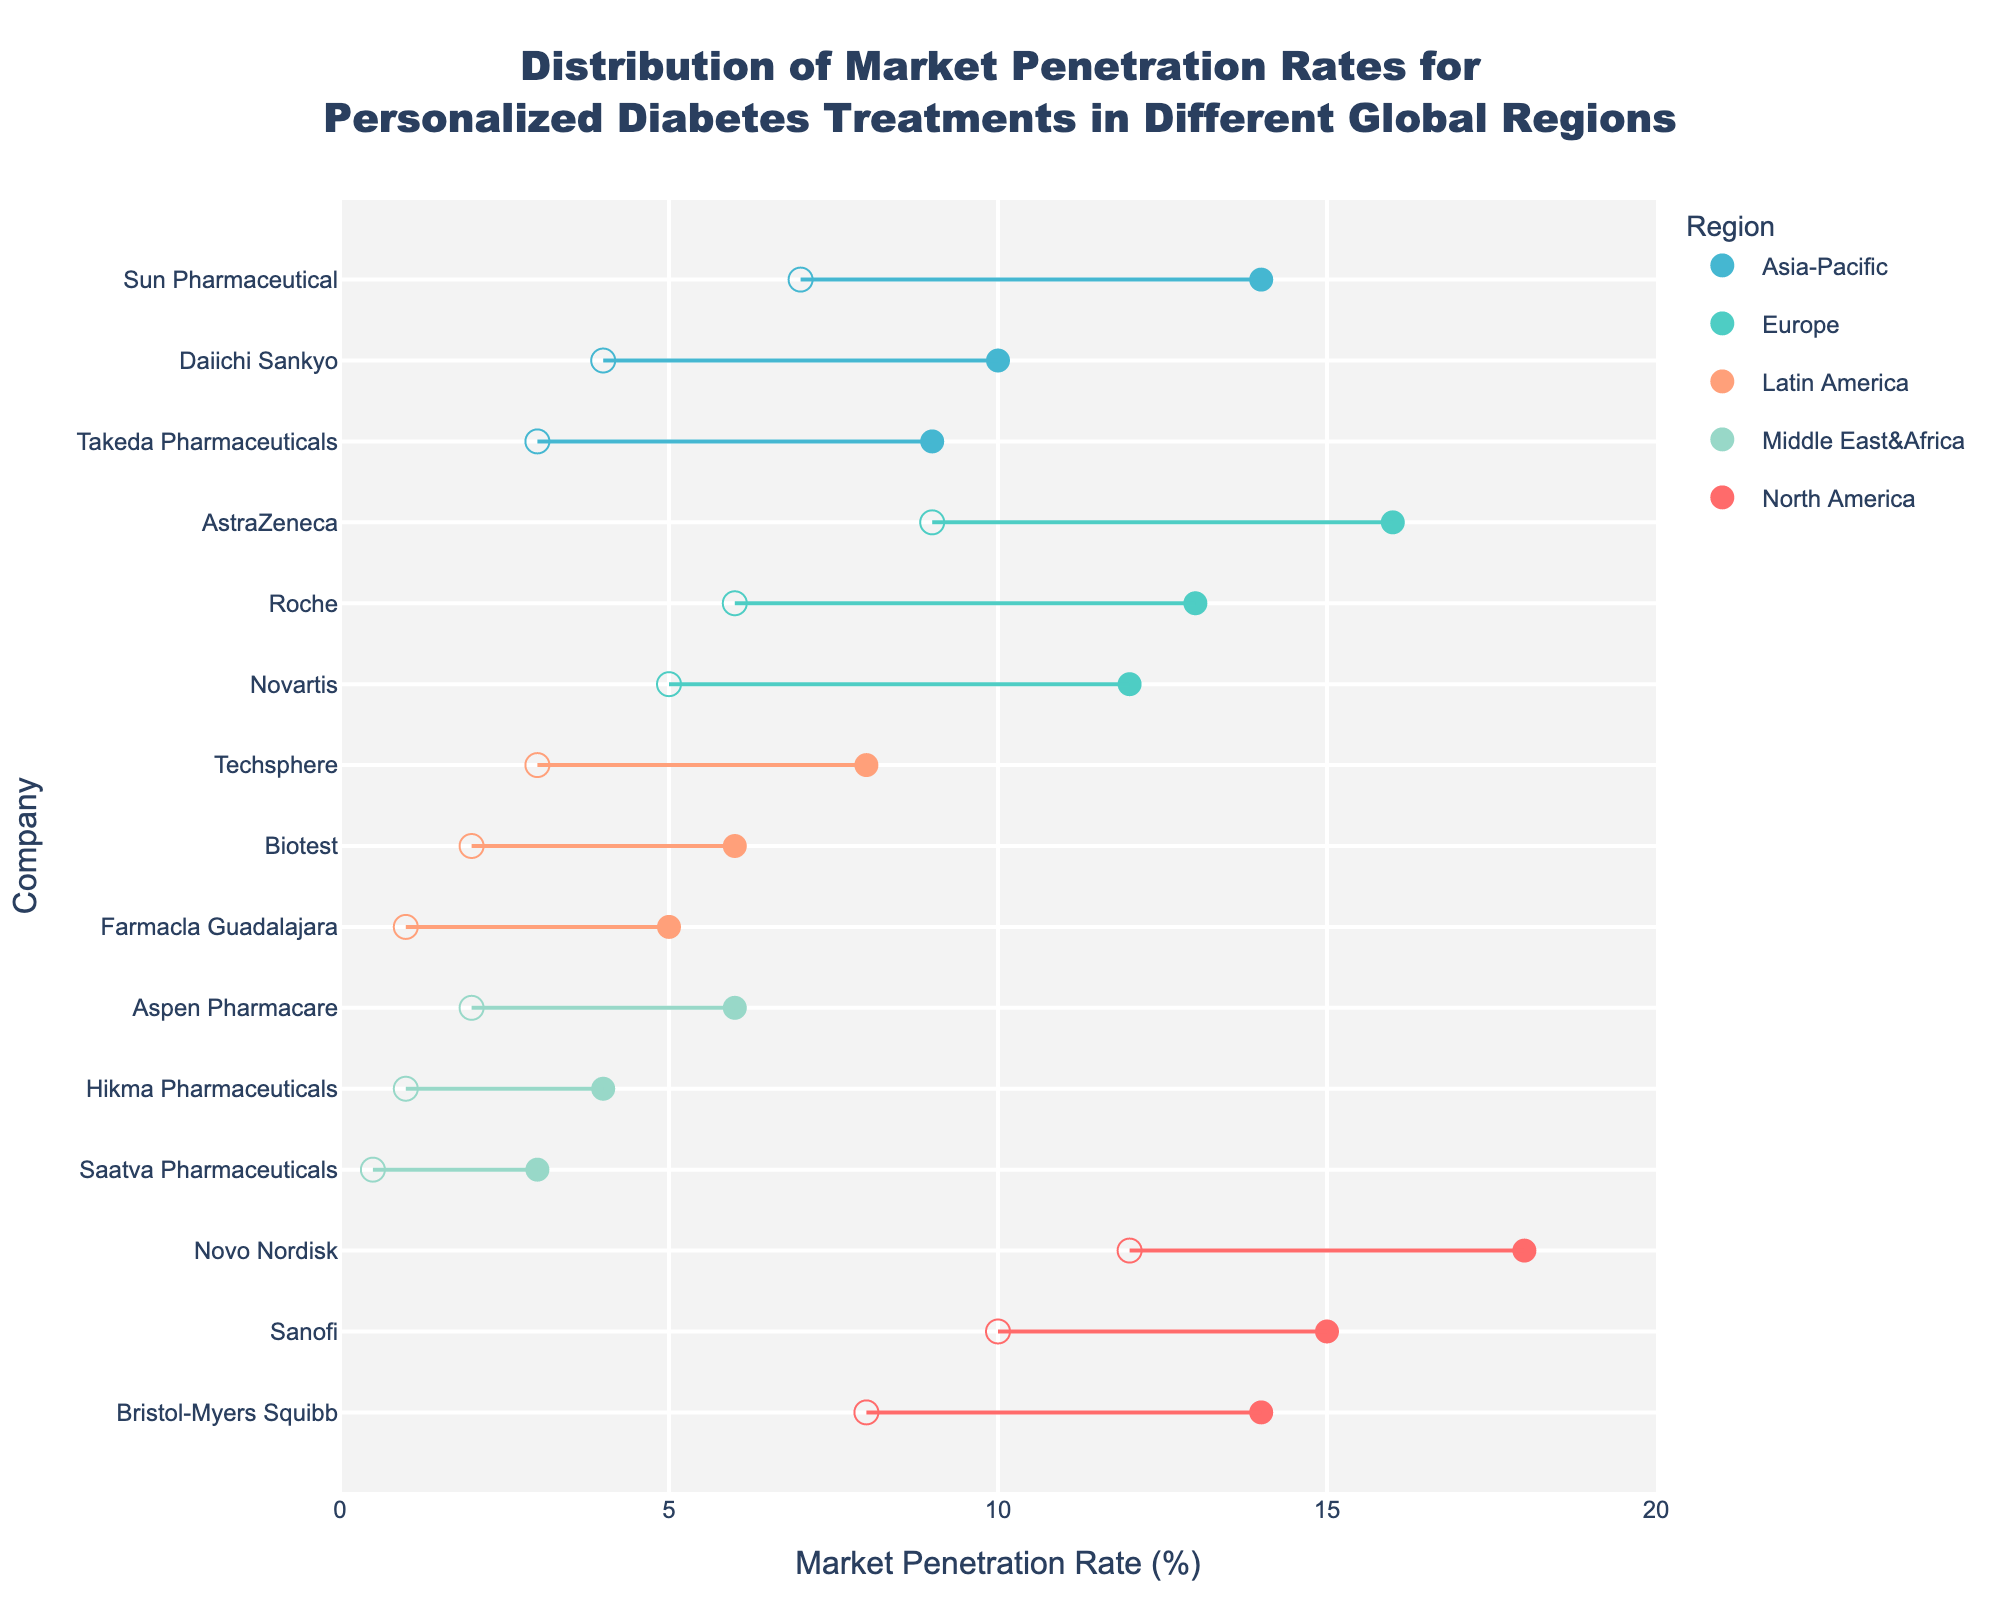What is the maximum market penetration rate for Novo Nordisk in North America? According to the figure, the maximum market penetration rate can be determined by finding where Novo Nordisk is represented in the North America region. The dot for Novo Nordisk in the North America section of the plot reaches up to a value of 18%.
Answer: 18% Which region has the company with the widest range of market penetration rates? The range can be calculated by subtracting the minimum penetration rate from the maximum for each company and then comparing these ranges. For example, Novo Nordisk in North America has a range of 18% - 12% = 6%. By checking each region, the Middle East&Africa with Saatva Pharmaceuticals (3% - 0.5% = 2.5%) and North America with Novo Nordisk (6%) have the widest ranges. Hence, comparing all regions, we find North America has the widest range.
Answer: North America Which region shows the lowest maximum penetration rate and what is the value? To find this, check the maximum penetration rates plotted for each region. The Middle East&Africa shows the lowest maximum penetration rate with Saatva Pharmaceuticals reaching up to 3%.
Answer: Middle East&Africa, 3% What is the average maximum penetration rate for companies in Europe? Calculate the average by adding the maximum penetration rates of AstraZeneca (16%), Novartis (12%), and Roche (13%) then dividing by the number of companies in Europe.
(16 + 12 + 13) / 3 = 41 / 3 = 13.67
Answer: 13.67% Which company in Latin America has the highest maximum penetration rate? Identify all data points under the Latin America region on the plot and find the highest maximum value. Techsphere has the highest maximum penetration rate reaching up to 8%.
Answer: Techsphere Compare the minimum market penetration rates between Takeda Pharmaceuticals and Daiichi Sankyo in Asia-Pacific. Which one is higher? For this comparison, we need to check the minimum market penetration rates for both companies. Takeda Pharmaceuticals has a minimum penetration rate of 3% and Daiichi Sankyo has a minimum penetration rate of 4%. Thus, Daiichi Sankyo's minimum rate is higher.
Answer: Daiichi Sankyo Among the companies in North America, which has the narrowest market penetration range? Calculate the range for each company in North America by subtracting their minimum rate from their maximum rate. For example, Novo Nordisk has a range of 6% (18% - 12%). Sanofi has a range of 5% (15% - 10%). Bristol-Myers Squibb has a range of 6% (14% - 8%). Sanofi has the narrowest range.
Answer: Sanofi What is the difference between the maximum market penetration rates of the top-performing companies in North America and Europe? Identify the highest penetration rate in North America (Novo Nordisk, 18%) and Europe (AstraZeneca, 16%). Subtract the European value from the North American value: 18% - 16% = 2%.
Answer: 2% Which region represents the company with the highest minimum market penetration rate? Examine the minimum penetration rates across companies in each region and determine the highest value. Novo Nordisk in North America has a minimum penetration rate of 12%, which is the highest minimum rate among all regions.
Answer: North America 